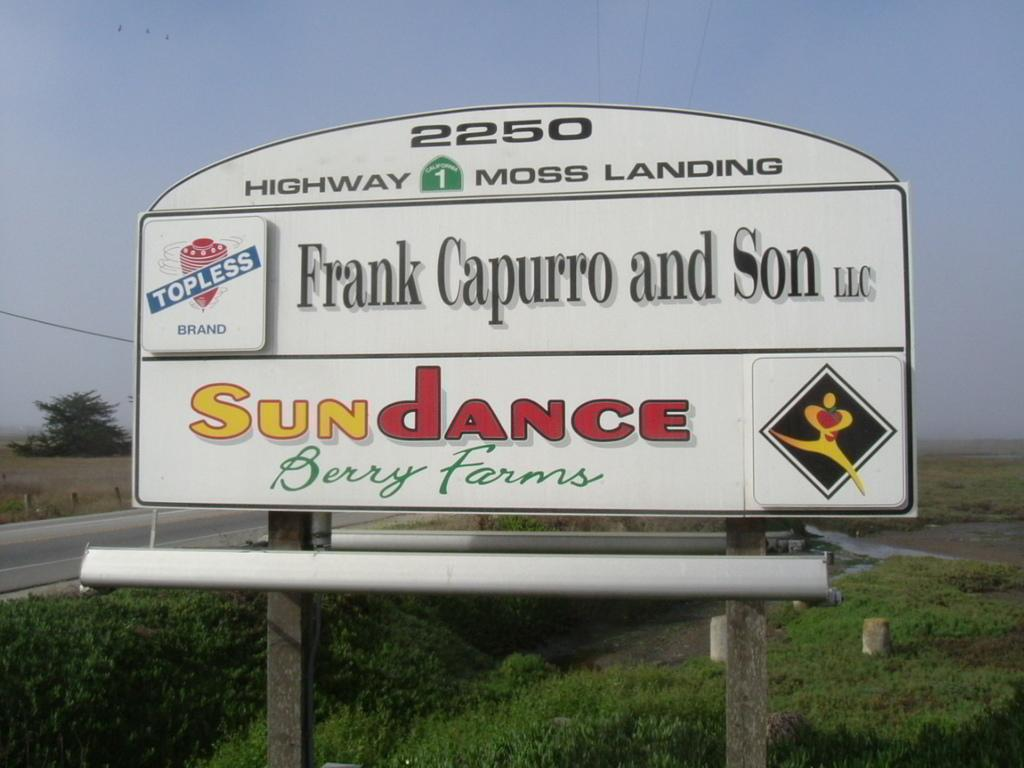<image>
Describe the image concisely. A sign for Sundance Berry farms is on the side of a road. 